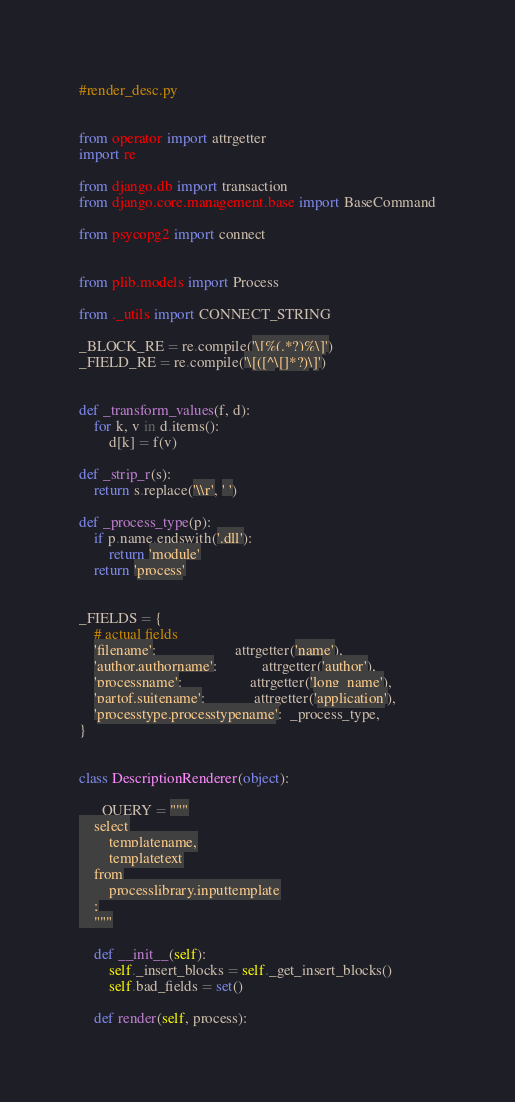<code> <loc_0><loc_0><loc_500><loc_500><_Python_>#render_desc.py


from operator import attrgetter
import re

from django.db import transaction
from django.core.management.base import BaseCommand

from psycopg2 import connect


from plib.models import Process

from ._utils import CONNECT_STRING
 
_BLOCK_RE = re.compile('\[%(.*?)%\]')
_FIELD_RE = re.compile('\[([^\[]*?)\]')


def _transform_values(f, d):
    for k, v in d.items():
        d[k] = f(v)

def _strip_r(s):
    return s.replace('\\r', ' ')

def _process_type(p):
    if p.name.endswith('.dll'):
        return 'module'
    return 'process'


_FIELDS = {
    # actual fields
    'filename':                     attrgetter('name'),
    'author.authorname':            attrgetter('author'),
    'processname':                  attrgetter('long_name'),
    'partof.suitename':             attrgetter('application'),
    'processtype.processtypename':  _process_type,
}


class DescriptionRenderer(object):

    _QUERY = """
    select
        templatename,
        templatetext
    from
        processlibrary.inputtemplate
    ;
    """

    def __init__(self):
        self._insert_blocks = self._get_insert_blocks()
        self.bad_fields = set()

    def render(self, process):</code> 